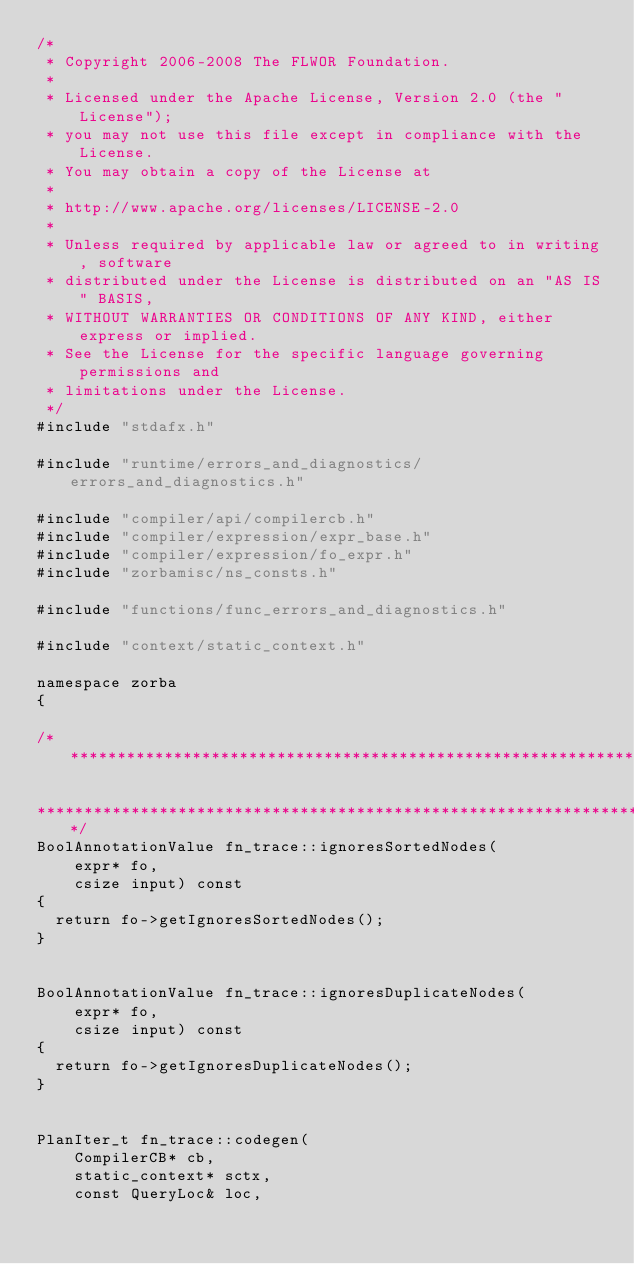<code> <loc_0><loc_0><loc_500><loc_500><_C++_>/*
 * Copyright 2006-2008 The FLWOR Foundation.
 *
 * Licensed under the Apache License, Version 2.0 (the "License");
 * you may not use this file except in compliance with the License.
 * You may obtain a copy of the License at
 *
 * http://www.apache.org/licenses/LICENSE-2.0
 *
 * Unless required by applicable law or agreed to in writing, software
 * distributed under the License is distributed on an "AS IS" BASIS,
 * WITHOUT WARRANTIES OR CONDITIONS OF ANY KIND, either express or implied.
 * See the License for the specific language governing permissions and
 * limitations under the License.
 */
#include "stdafx.h"

#include "runtime/errors_and_diagnostics/errors_and_diagnostics.h"

#include "compiler/api/compilercb.h"
#include "compiler/expression/expr_base.h"
#include "compiler/expression/fo_expr.h"
#include "zorbamisc/ns_consts.h"

#include "functions/func_errors_and_diagnostics.h"

#include "context/static_context.h"

namespace zorba
{

/*******************************************************************************

********************************************************************************/
BoolAnnotationValue fn_trace::ignoresSortedNodes(
    expr* fo,
    csize input) const 
{
  return fo->getIgnoresSortedNodes();
}


BoolAnnotationValue fn_trace::ignoresDuplicateNodes(
    expr* fo, 
    csize input) const 
{
  return fo->getIgnoresDuplicateNodes();
}


PlanIter_t fn_trace::codegen(
    CompilerCB* cb,
    static_context* sctx,
    const QueryLoc& loc,</code> 